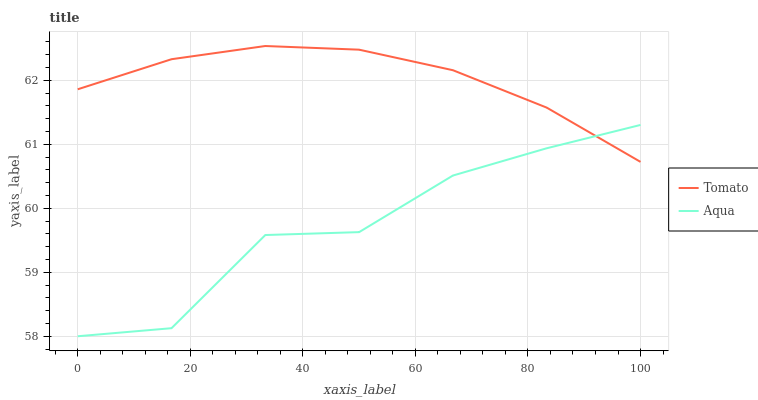Does Aqua have the minimum area under the curve?
Answer yes or no. Yes. Does Tomato have the maximum area under the curve?
Answer yes or no. Yes. Does Aqua have the maximum area under the curve?
Answer yes or no. No. Is Tomato the smoothest?
Answer yes or no. Yes. Is Aqua the roughest?
Answer yes or no. Yes. Is Aqua the smoothest?
Answer yes or no. No. Does Aqua have the lowest value?
Answer yes or no. Yes. Does Tomato have the highest value?
Answer yes or no. Yes. Does Aqua have the highest value?
Answer yes or no. No. Does Aqua intersect Tomato?
Answer yes or no. Yes. Is Aqua less than Tomato?
Answer yes or no. No. Is Aqua greater than Tomato?
Answer yes or no. No. 